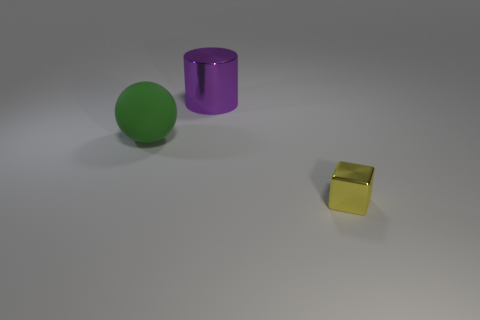Add 1 large cylinders. How many objects exist? 4 Subtract all balls. How many objects are left? 2 Add 1 small shiny things. How many small shiny things are left? 2 Add 1 small green things. How many small green things exist? 1 Subtract 0 gray cylinders. How many objects are left? 3 Subtract all metallic cylinders. Subtract all yellow shiny things. How many objects are left? 1 